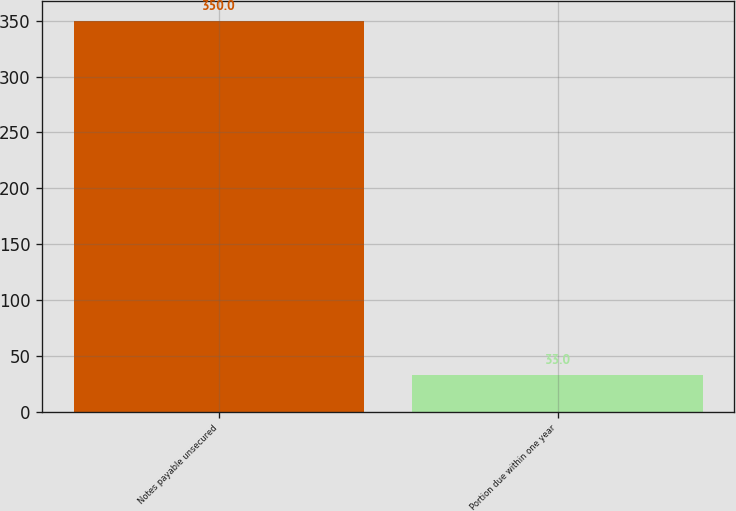Convert chart. <chart><loc_0><loc_0><loc_500><loc_500><bar_chart><fcel>Notes payable unsecured<fcel>Portion due within one year<nl><fcel>350<fcel>33<nl></chart> 